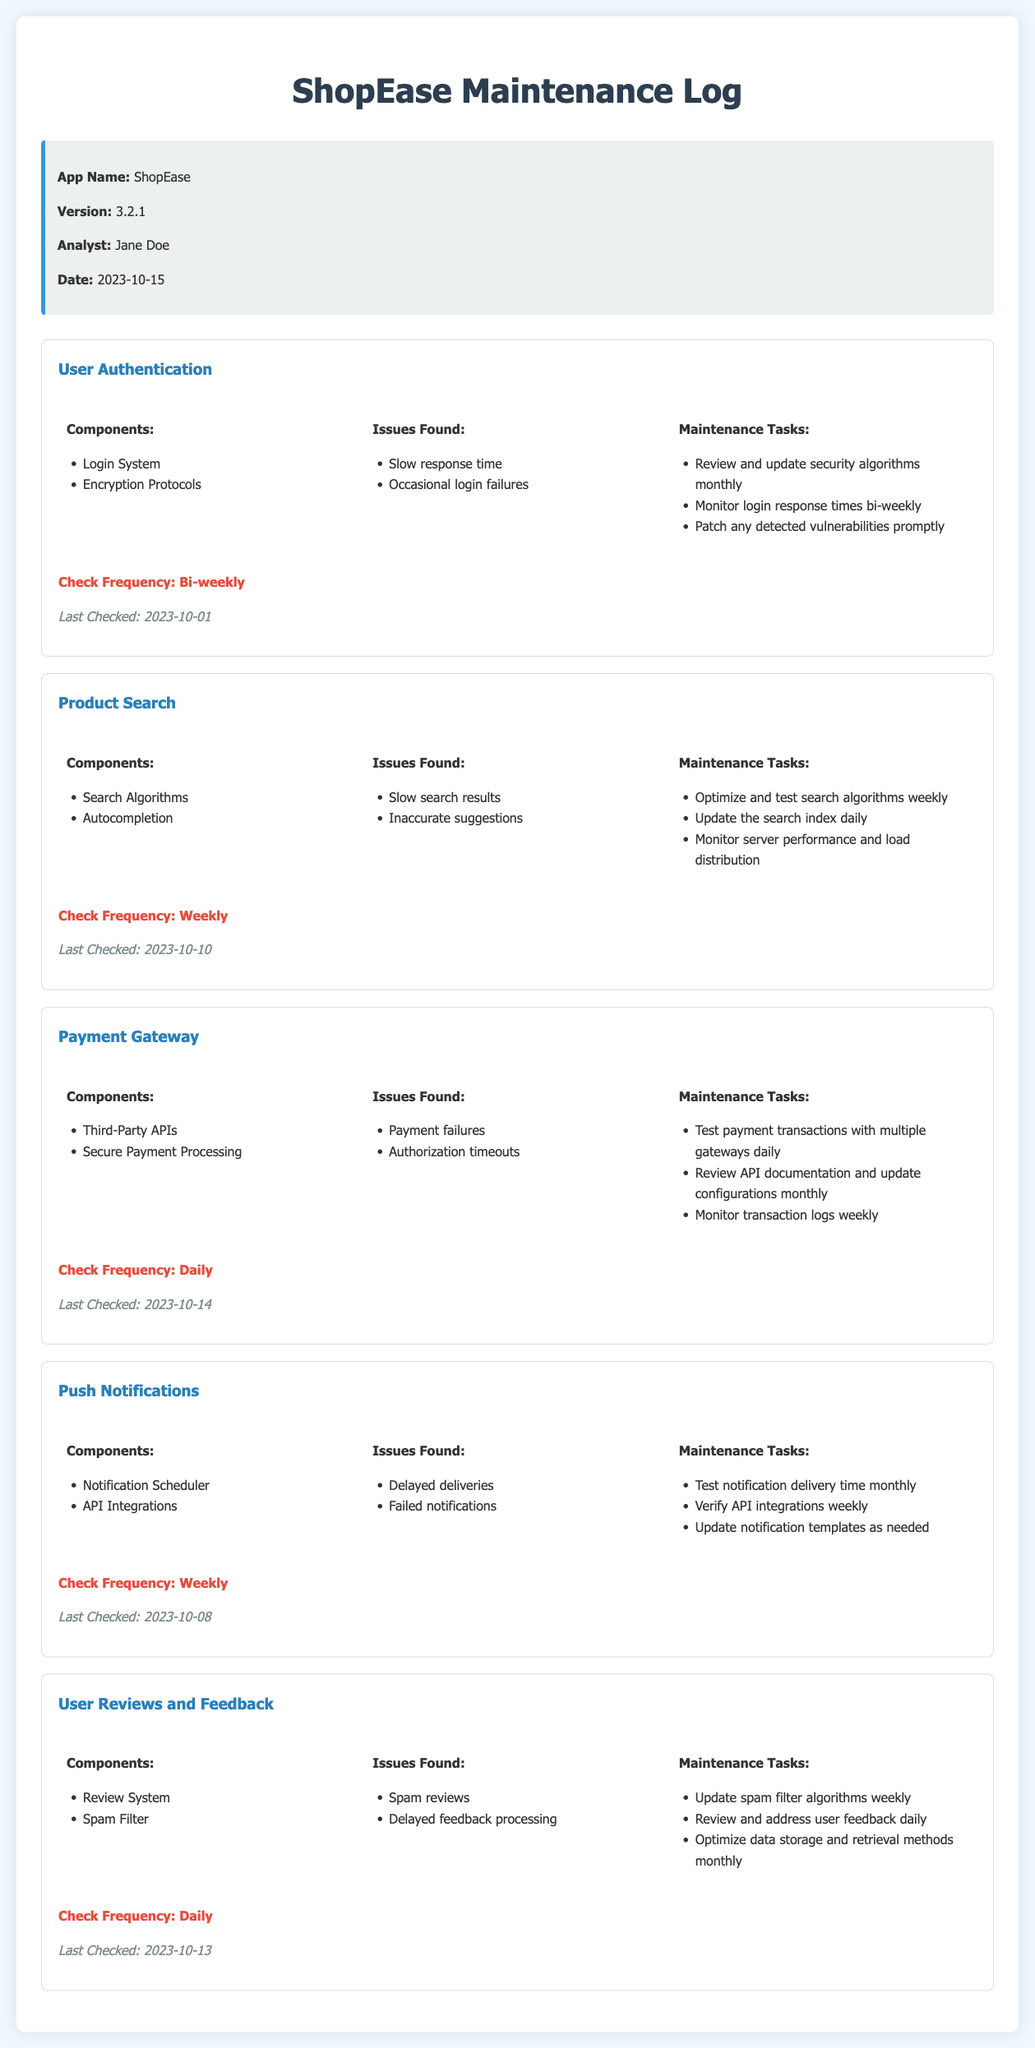What is the app name? The app name is specified in the document as "ShopEase."
Answer: ShopEase Who is the analyst? The analyst is mentioned in the document as "Jane Doe."
Answer: Jane Doe When was the last check for the Payment Gateway? The last check date for the Payment Gateway is detailed in the document.
Answer: 2023-10-14 How often should the User Authentication be checked? The checking frequency for User Authentication is specified in the document.
Answer: Bi-weekly What issues were found in the Product Search? The document lists the issues found under the Product Search section.
Answer: Slow search results, Inaccurate suggestions What maintenance task is associated with User Reviews and Feedback? One of the maintenance tasks for User Reviews and Feedback is mentioned in the document.
Answer: Update spam filter algorithms weekly How many components are listed for Push Notifications? The document states the number of components mentioned.
Answer: 2 What is the check frequency for the Payment Gateway? The frequency of checks for the Payment Gateway is provided in the document.
Answer: Daily What issues are associated with the Payment Gateway? The issues for the Payment Gateway are listed in the document.
Answer: Payment failures, Authorization timeouts 